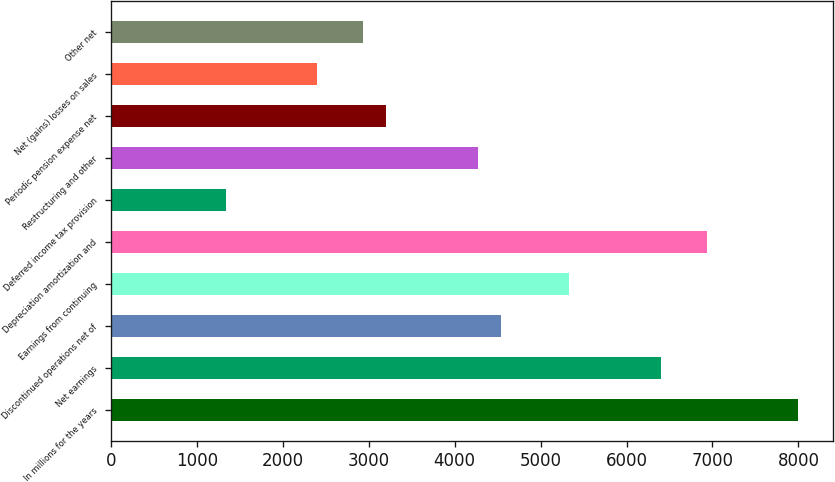<chart> <loc_0><loc_0><loc_500><loc_500><bar_chart><fcel>In millions for the years<fcel>Net earnings<fcel>Discontinued operations net of<fcel>Earnings from continuing<fcel>Depreciation amortization and<fcel>Deferred income tax provision<fcel>Restructuring and other<fcel>Periodic pension expense net<fcel>Net (gains) losses on sales<fcel>Other net<nl><fcel>7999<fcel>6400<fcel>4534.5<fcel>5334<fcel>6933<fcel>1336.5<fcel>4268<fcel>3202<fcel>2402.5<fcel>2935.5<nl></chart> 